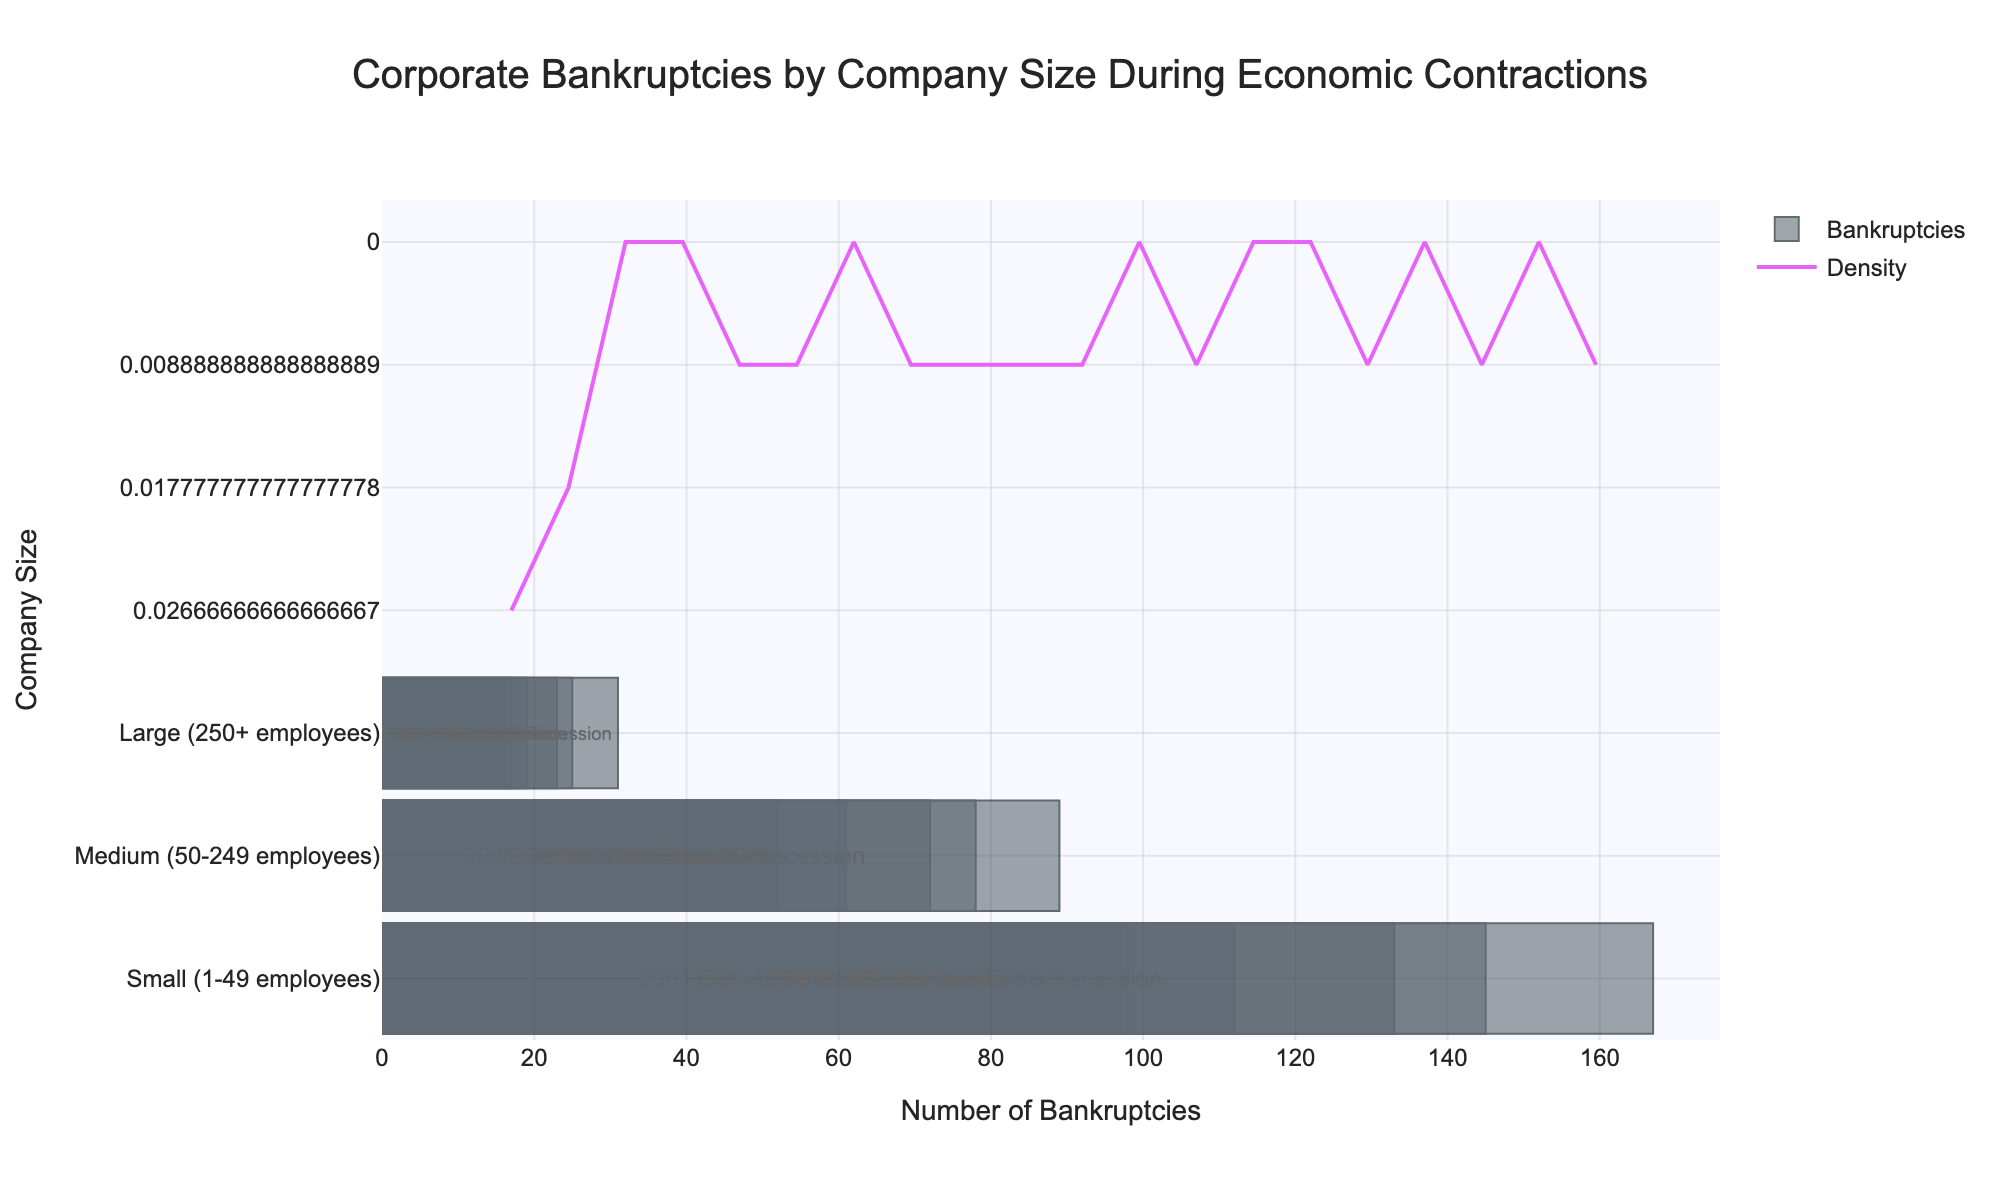What is the title of the plot? The title is displayed at the top center of the plot and reads "Corporate Bankruptcies by Company Size During Economic Contractions".
Answer: Corporate Bankruptcies by Company Size During Economic Contractions What are the company sizes depicted in the figure? The company sizes are listed along the y-axis, and they are "Small (1-49 employees)", "Medium (50-249 employees)", and "Large (250+ employees)".
Answer: Small (1-49 employees), Medium (50-249 employees), Large (250+ employees) What does the density curve represent in the plot? The density curve represents the overall pattern or distribution of the number of corporate bankruptcies. It shows where the data points are concentrated.
Answer: Overall pattern of bankruptcies Which company size experienced the highest number of bankruptcies during economic contractions? By observing the x-axis values for each company size, the biggest values correspond to "Small (1-49 employees)".
Answer: Small (1-49 employees) How did the number of bankruptcies for large companies during the 2008 Financial Crisis compare to the 2020 COVID-19 Recession? By reading from the histogram bars, large companies had 23 bankruptcies during the 2008 Financial Crisis and 31 during the 2020 COVID-19 Recession. This indicates an increase.
Answer: Increased from 23 to 31 What economic contractions are labeled within the histogram bars? The economic contractions included in the figure are "2008 Financial Crisis", "2001 Dot-com Bubble", "2020 COVID-19 Recession", "1990-1991 Recession", and "1981-1982 Recession".
Answer: 2008 Financial Crisis, 2001 Dot-com Bubble, 2020 COVID-19 Recession, 1990-1991 Recession, 1981-1982 Recession How many bankruptcies were recorded for medium-sized companies during the 1981-1982 Recession? Referring to the histogram bar labeled for the 1981-1982 Recession and medium-sized companies, the number of bankruptcies recorded is 72.
Answer: 72 What is the trend shown by the density curve? The density curve has higher peaks at values corresponding to small companies' bankruptcies, indicating a higher frequency or concentration of bankruptcies at these values.
Answer: Higher frequency at small companies' bankruptcies Can you identify which economic contraction had the lowest number of bankruptcies for medium-sized companies? Observing the histogram bars for medium-sized companies, the lowest number appears during the "2001 Dot-com Bubble" with 52 bankruptcies.
Answer: 2001 Dot-com Bubble What's the difference in the number of bankruptcies between small and large companies during the 2020 COVID-19 Recession? Small companies had 167 bankruptcies and large companies had 31. The difference is calculated as 167 - 31 = 136.
Answer: 136 